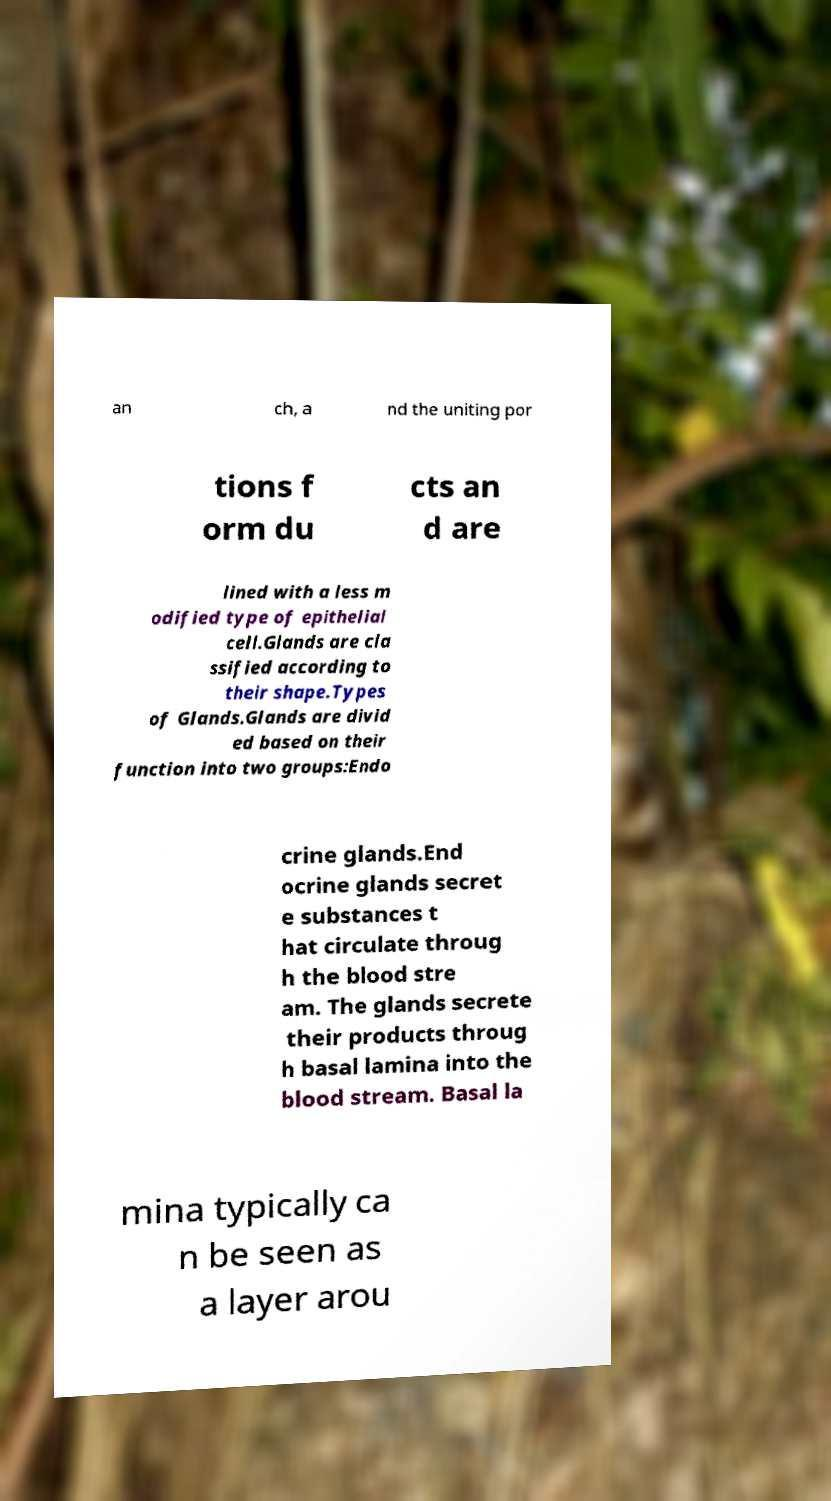Could you extract and type out the text from this image? an ch, a nd the uniting por tions f orm du cts an d are lined with a less m odified type of epithelial cell.Glands are cla ssified according to their shape.Types of Glands.Glands are divid ed based on their function into two groups:Endo crine glands.End ocrine glands secret e substances t hat circulate throug h the blood stre am. The glands secrete their products throug h basal lamina into the blood stream. Basal la mina typically ca n be seen as a layer arou 